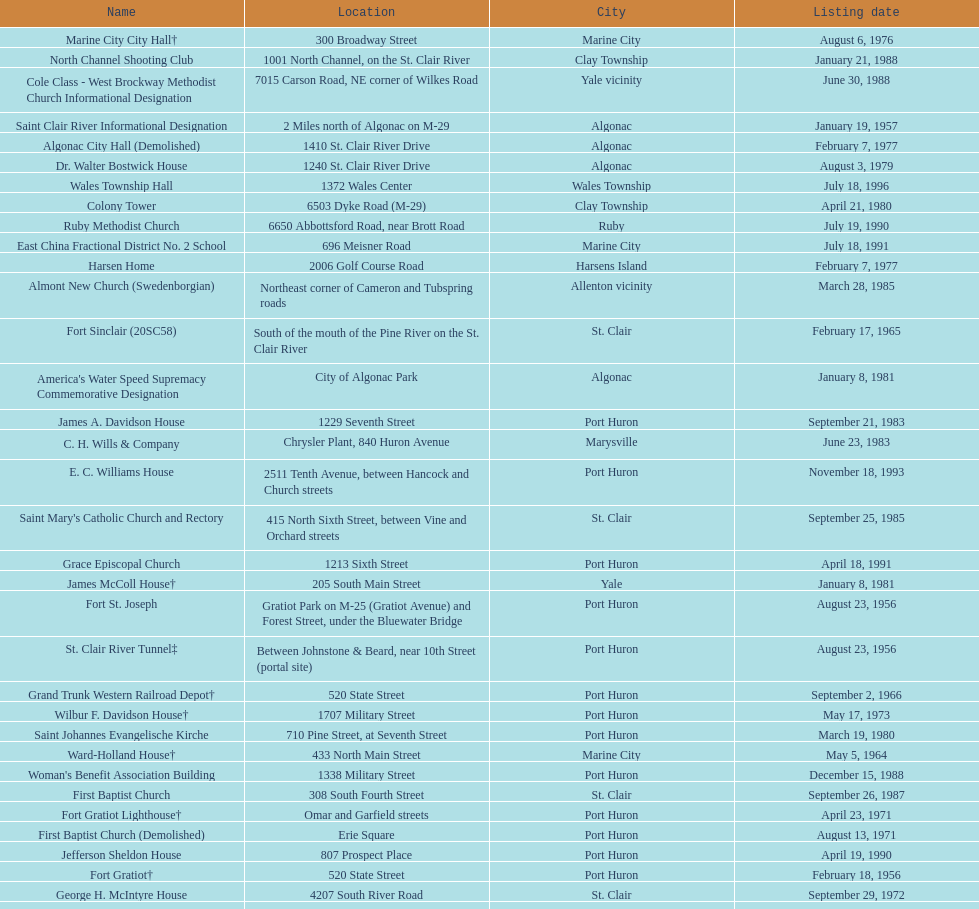What is the number of properties on the list that have been demolished? 2. 